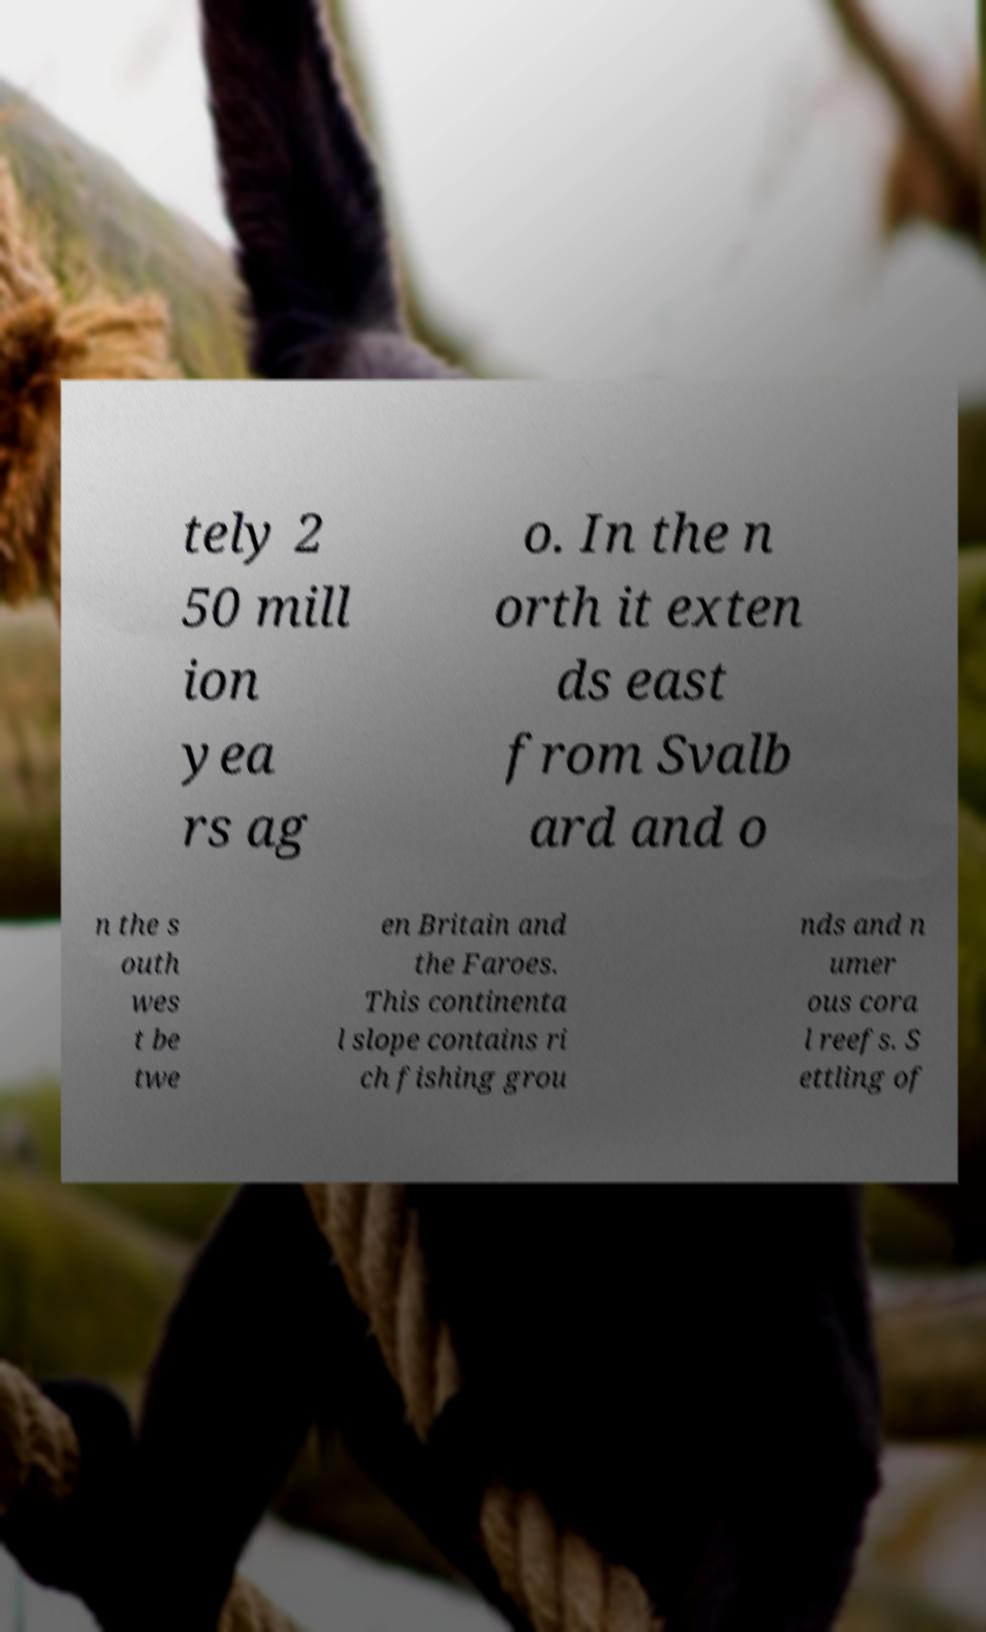I need the written content from this picture converted into text. Can you do that? tely 2 50 mill ion yea rs ag o. In the n orth it exten ds east from Svalb ard and o n the s outh wes t be twe en Britain and the Faroes. This continenta l slope contains ri ch fishing grou nds and n umer ous cora l reefs. S ettling of 